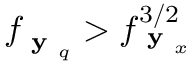<formula> <loc_0><loc_0><loc_500><loc_500>f _ { y _ { q } } > f _ { y _ { x } } ^ { 3 / 2 }</formula> 